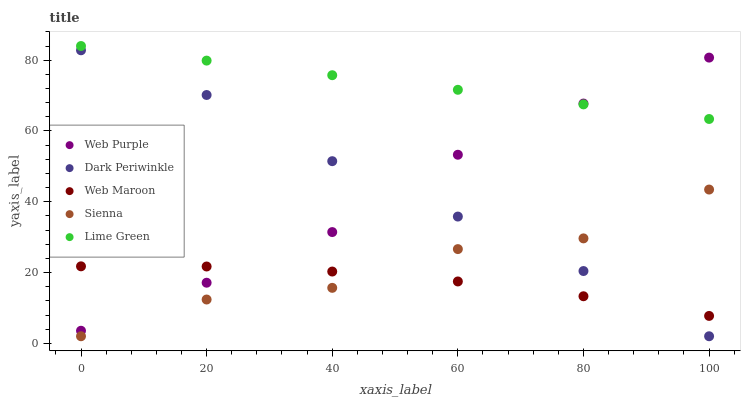Does Web Maroon have the minimum area under the curve?
Answer yes or no. Yes. Does Lime Green have the maximum area under the curve?
Answer yes or no. Yes. Does Web Purple have the minimum area under the curve?
Answer yes or no. No. Does Web Purple have the maximum area under the curve?
Answer yes or no. No. Is Lime Green the smoothest?
Answer yes or no. Yes. Is Sienna the roughest?
Answer yes or no. Yes. Is Web Purple the smoothest?
Answer yes or no. No. Is Web Purple the roughest?
Answer yes or no. No. Does Sienna have the lowest value?
Answer yes or no. Yes. Does Web Purple have the lowest value?
Answer yes or no. No. Does Lime Green have the highest value?
Answer yes or no. Yes. Does Web Purple have the highest value?
Answer yes or no. No. Is Dark Periwinkle less than Lime Green?
Answer yes or no. Yes. Is Lime Green greater than Sienna?
Answer yes or no. Yes. Does Dark Periwinkle intersect Web Maroon?
Answer yes or no. Yes. Is Dark Periwinkle less than Web Maroon?
Answer yes or no. No. Is Dark Periwinkle greater than Web Maroon?
Answer yes or no. No. Does Dark Periwinkle intersect Lime Green?
Answer yes or no. No. 